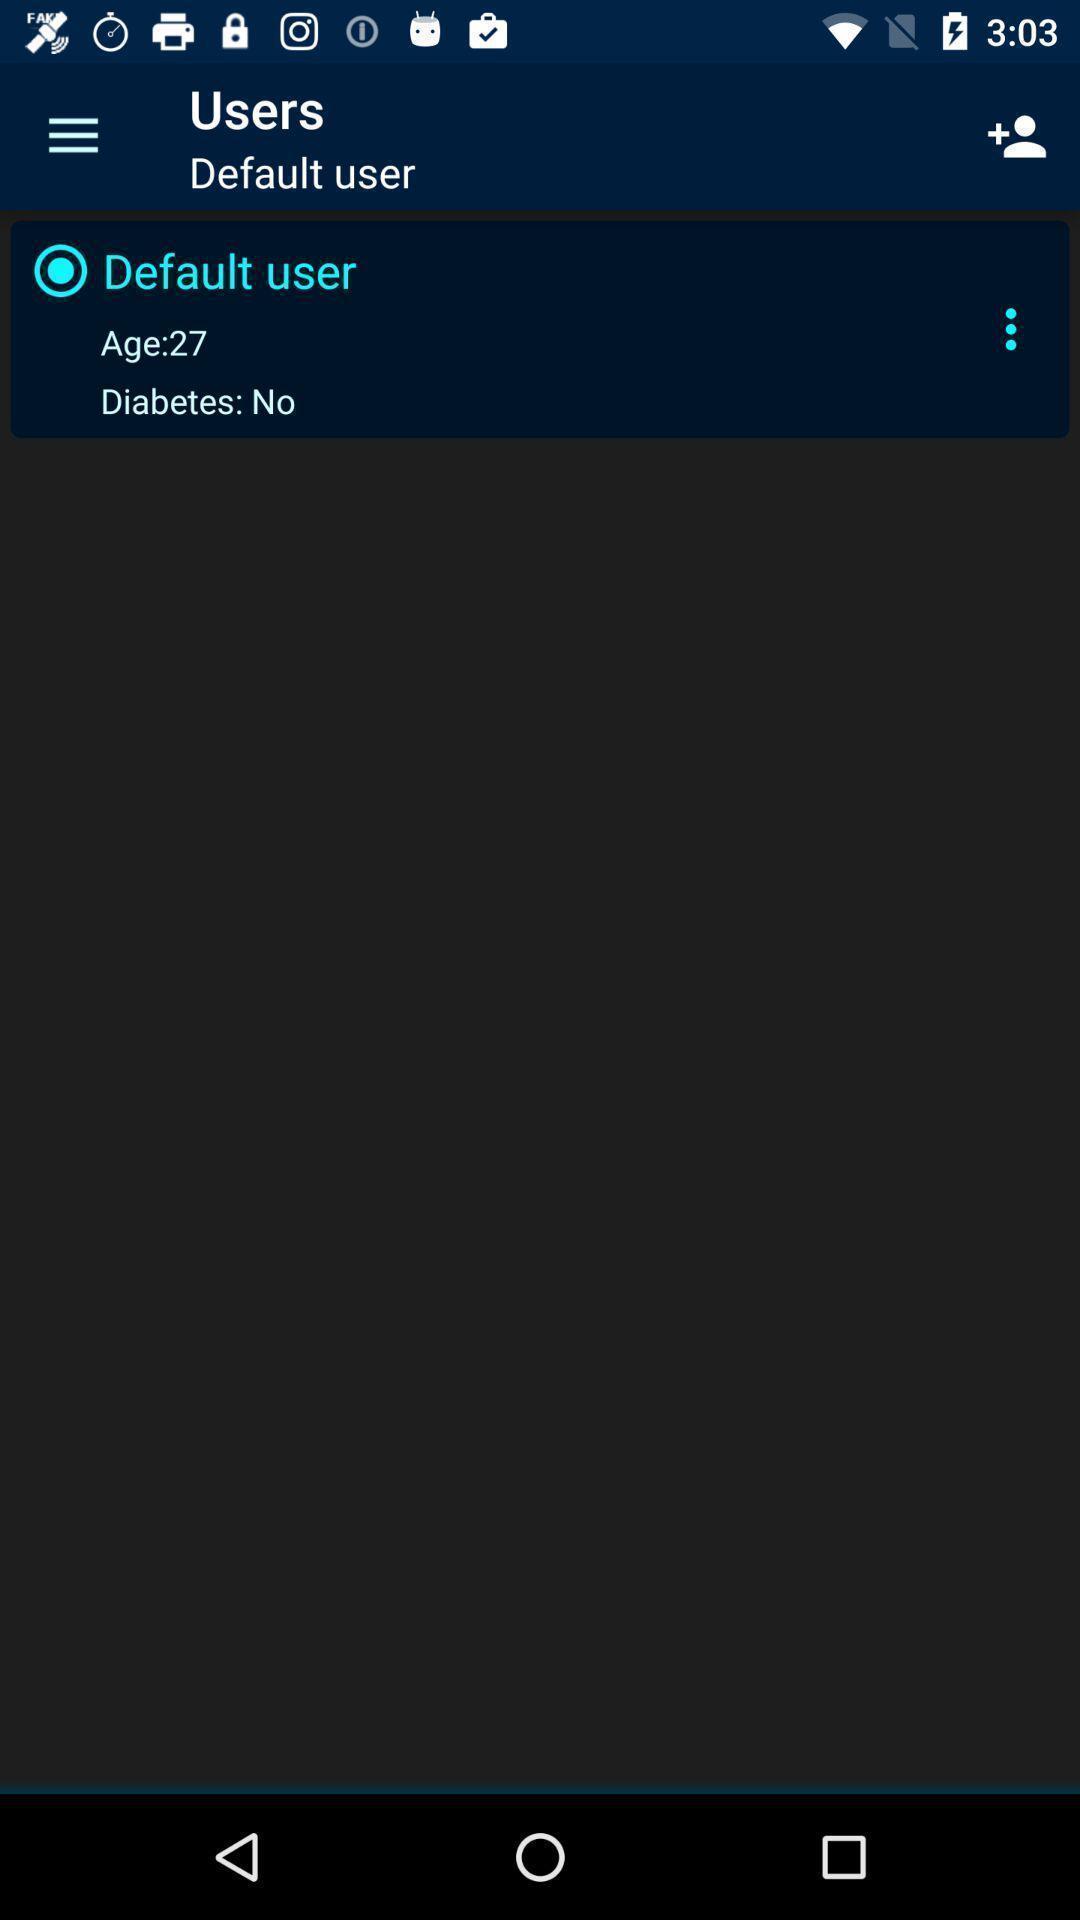Provide a detailed account of this screenshot. Page showing users. 